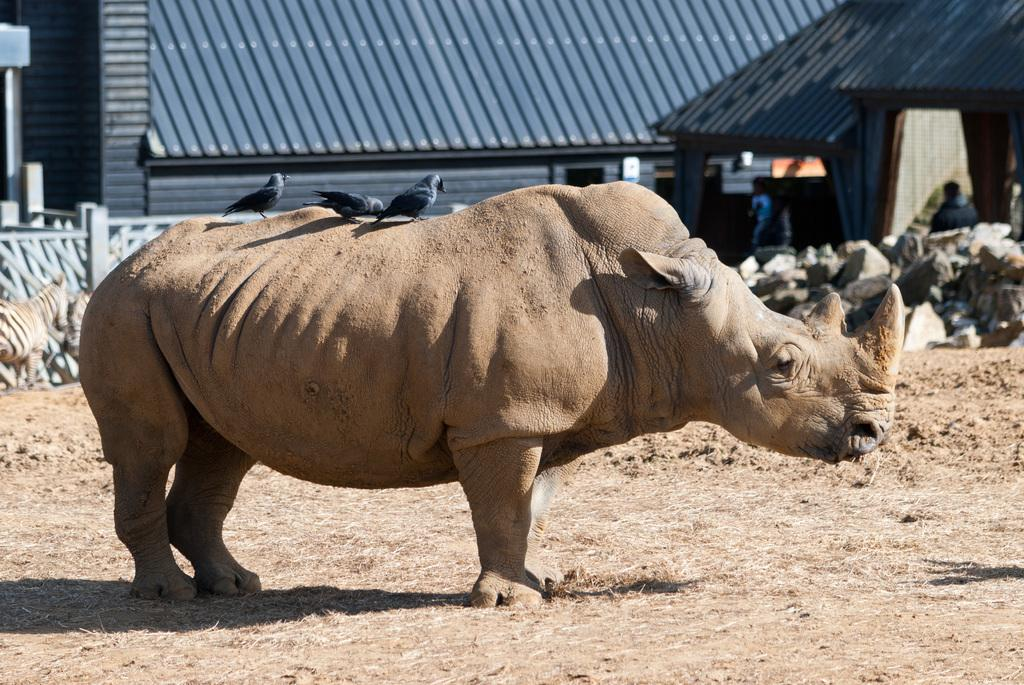What type of animal is standing on the grass in the image? The animal's specific type is not mentioned, but it is standing on the grass in the image. What is on top of the animal? There are crows on the animal. What can be seen in the distance in the image? Rocks and a shed are visible in the background of the image. What type of cheese is being served for dinner in the image? There is no mention of cheese or dinner in the image; it features an animal with crows on it and a background with rocks and a shed. 